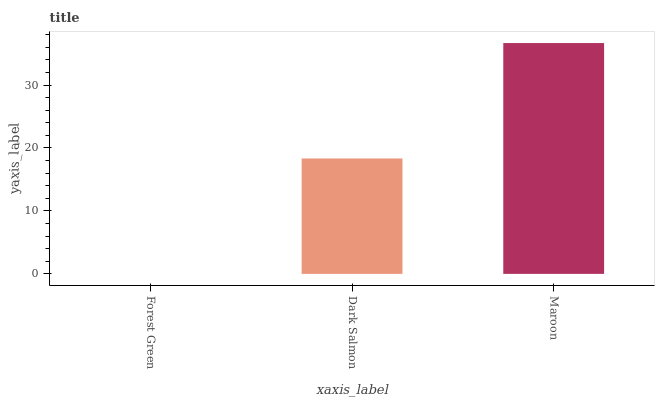Is Forest Green the minimum?
Answer yes or no. Yes. Is Maroon the maximum?
Answer yes or no. Yes. Is Dark Salmon the minimum?
Answer yes or no. No. Is Dark Salmon the maximum?
Answer yes or no. No. Is Dark Salmon greater than Forest Green?
Answer yes or no. Yes. Is Forest Green less than Dark Salmon?
Answer yes or no. Yes. Is Forest Green greater than Dark Salmon?
Answer yes or no. No. Is Dark Salmon less than Forest Green?
Answer yes or no. No. Is Dark Salmon the high median?
Answer yes or no. Yes. Is Dark Salmon the low median?
Answer yes or no. Yes. Is Forest Green the high median?
Answer yes or no. No. Is Forest Green the low median?
Answer yes or no. No. 